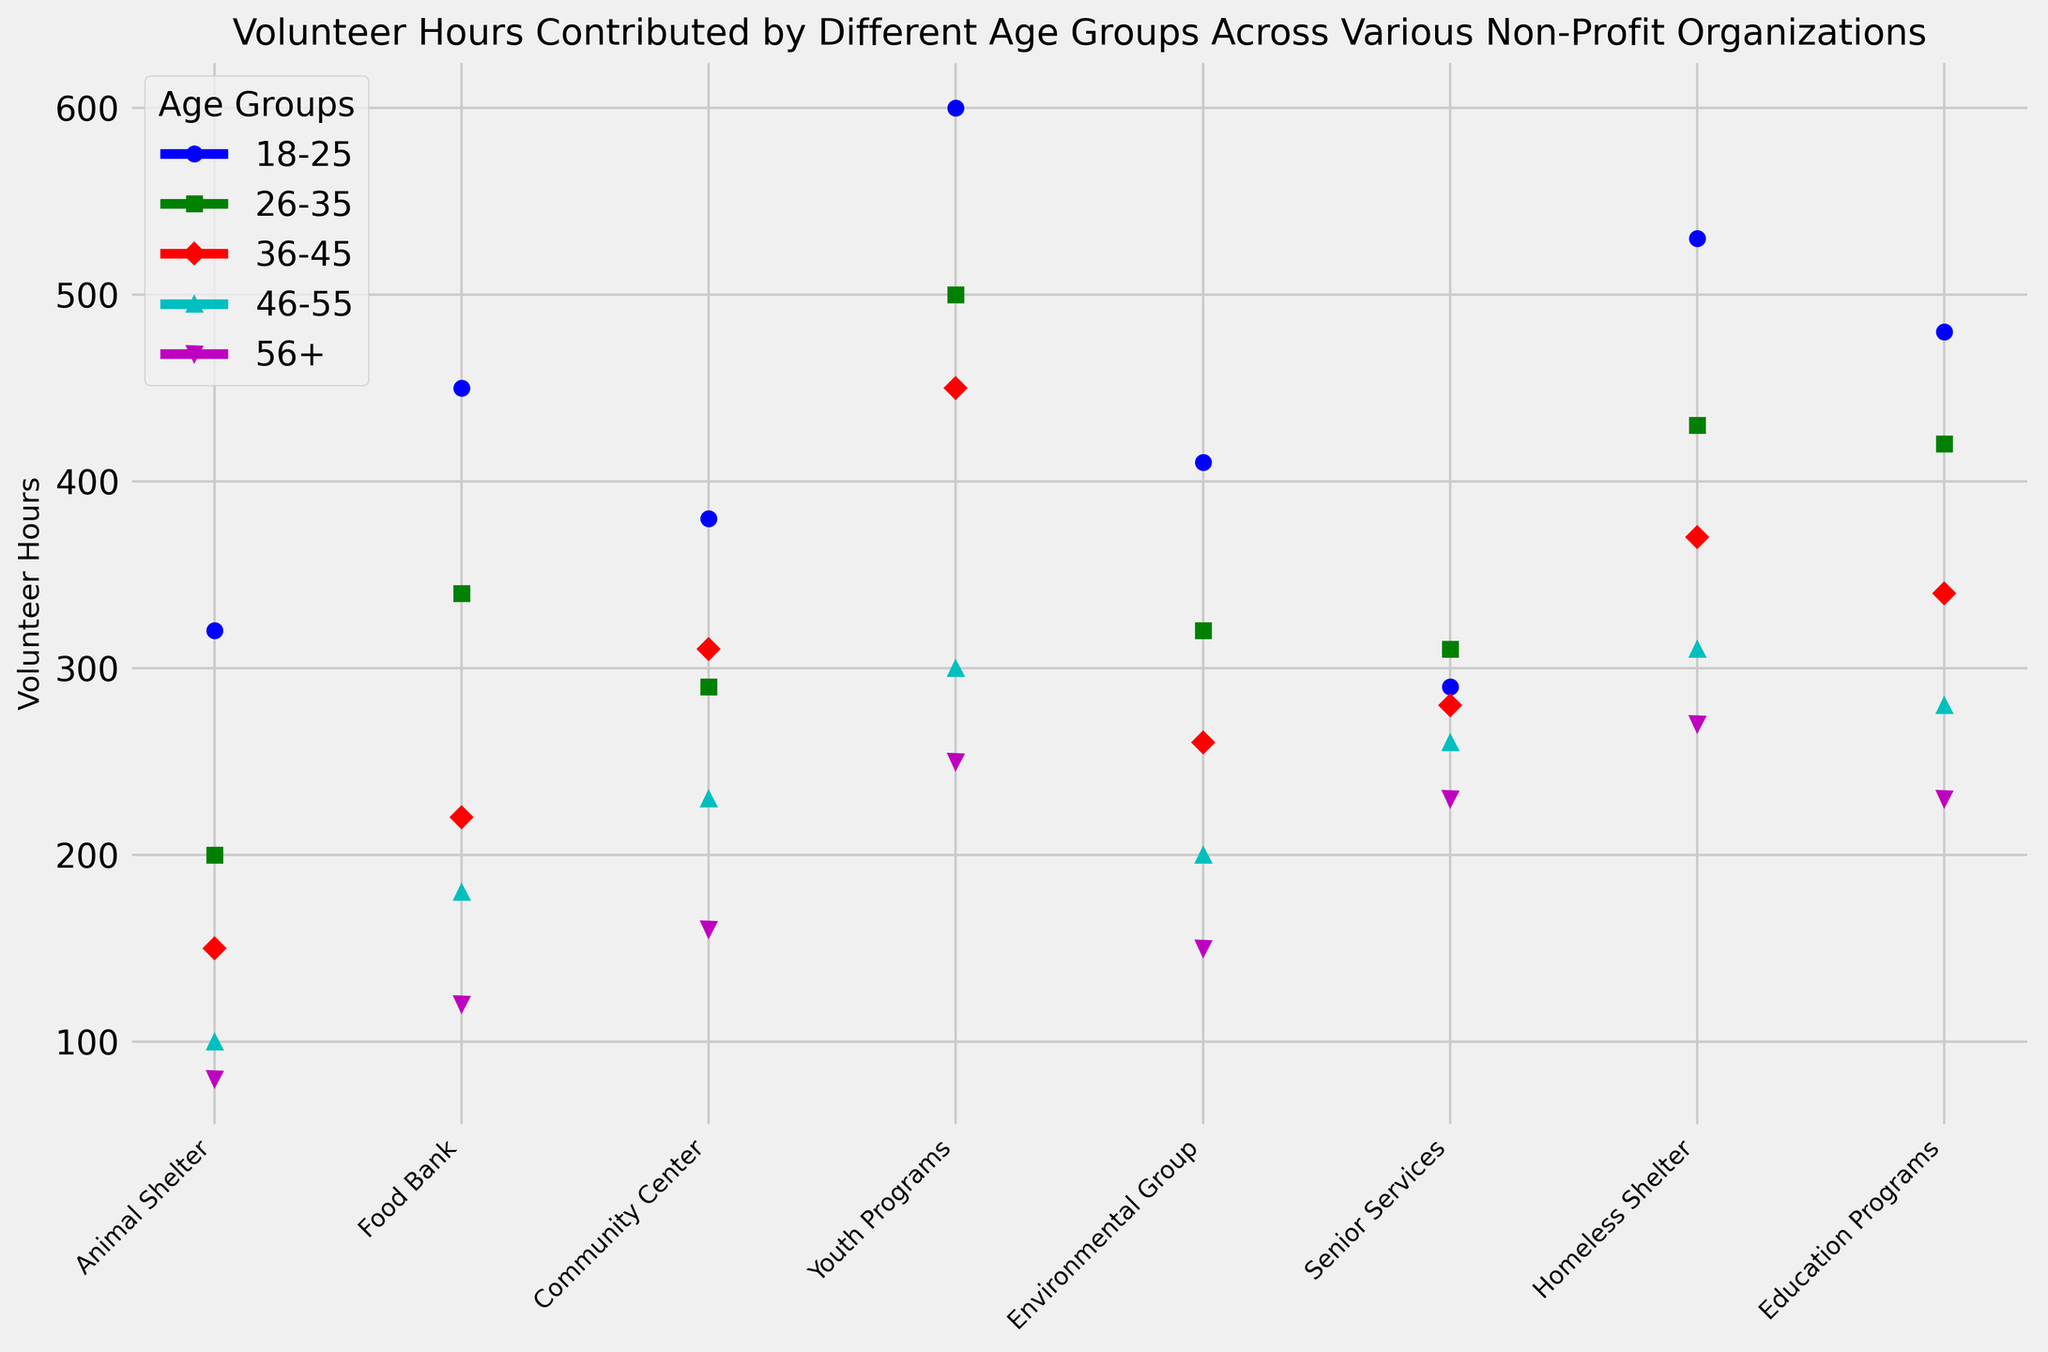Which age group contributed the most volunteer hours overall? Sum the volunteer hours for each age group across all organizations and compare them. For 18-25: 320+450+380+600+410+290+530+480 = 3460; 26-35: 200+340+290+500+320+310+430+420 = 2810; 36-45: 150+220+310+450+260+280+370+340 = 2380; 46-55: 100+180+230+300+200+260+310+280 = 1860; 56+: 80+120+160+250+150+230+270+230 = 1490. The 18-25 age group has the highest total.
Answer: 18-25 Which organization received the most volunteer hours from the 26-35 age group? Check the volunteer hours contributed by the 26-35 age group in each organization: Animal Shelter (200), Food Bank (340), Community Center (290), Youth Programs (500), Environmental Group (320), Senior Services (310), Homeless Shelter (430), Education Programs (420). Youth Programs has the highest with 500 hours.
Answer: Youth Programs How many more volunteer hours did the Education Programs receive from the 18-25 age group compared to the 46-55 age group? Subtract the volunteer hours for the 46-55 age group from the 18-25 age group for Education Programs: 480 (18-25) - 280 (46-55) = 200.
Answer: 200 Which age group contributed the least volunteer hours to the Animal Shelter? Review the volunteer hours for each age group for the Animal Shelter: 18-25 (320), 26-35 (200), 36-45 (150), 46-55 (100), 56+ (80). The 56+ age group contributed the least with 80 hours.
Answer: 56+ Do youth programs receive more volunteer hours from the 36-45 age group than the combination of the 46-55 and 56+ age groups? Compare the volunteer hours for the 36-45 age group to the sum of the 46-55 and 56+ groups for Youth Programs: 36-45 (450), 46-55 + 56+ (300 + 250 = 550). The combination of 46-55 and 56+ groups is higher.
Answer: No What is the average number of volunteer hours contributed by the 56+ age group across all organizations? Calculate the average by summing the 56+ age group volunteer hours across all organizations and dividing by the number of organizations: (80+120+160+250+150+230+270+230)/8 = 1240/8 = 155.
Answer: 155 Which organization had the closest number of volunteer hours between the 18-25 and 36-45 age groups? Calculate the absolute difference in volunteer hours between the 18-25 and 36-45 age groups for each organization to find the smallest difference: Animal Shelter (320-150 = 170), Food Bank (450-220 = 230), Community Center (380-310 = 70), Youth Programs (600-450 = 150), Environmental Group (410-260 = 150), Senior Services (290-280 = 10), Homeless Shelter (530-370 = 160), Education Programs (480-340 = 140). Senior Services has the smallest difference.
Answer: Senior Services 